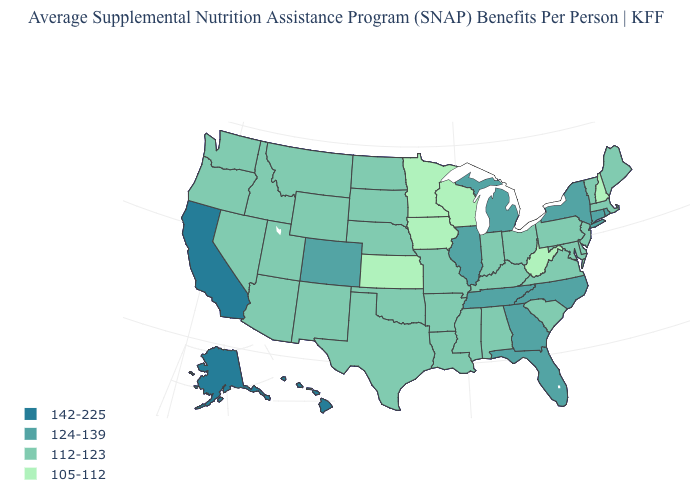Does the map have missing data?
Concise answer only. No. Is the legend a continuous bar?
Give a very brief answer. No. What is the value of Connecticut?
Quick response, please. 124-139. Which states have the lowest value in the West?
Answer briefly. Arizona, Idaho, Montana, Nevada, New Mexico, Oregon, Utah, Washington, Wyoming. Does the first symbol in the legend represent the smallest category?
Short answer required. No. What is the value of Virginia?
Keep it brief. 112-123. What is the value of Florida?
Give a very brief answer. 124-139. What is the value of Arkansas?
Write a very short answer. 112-123. Which states have the lowest value in the South?
Concise answer only. West Virginia. Name the states that have a value in the range 142-225?
Answer briefly. Alaska, California, Hawaii. Does Ohio have a lower value than Nebraska?
Answer briefly. No. What is the value of Ohio?
Answer briefly. 112-123. Does Vermont have the lowest value in the Northeast?
Answer briefly. No. 